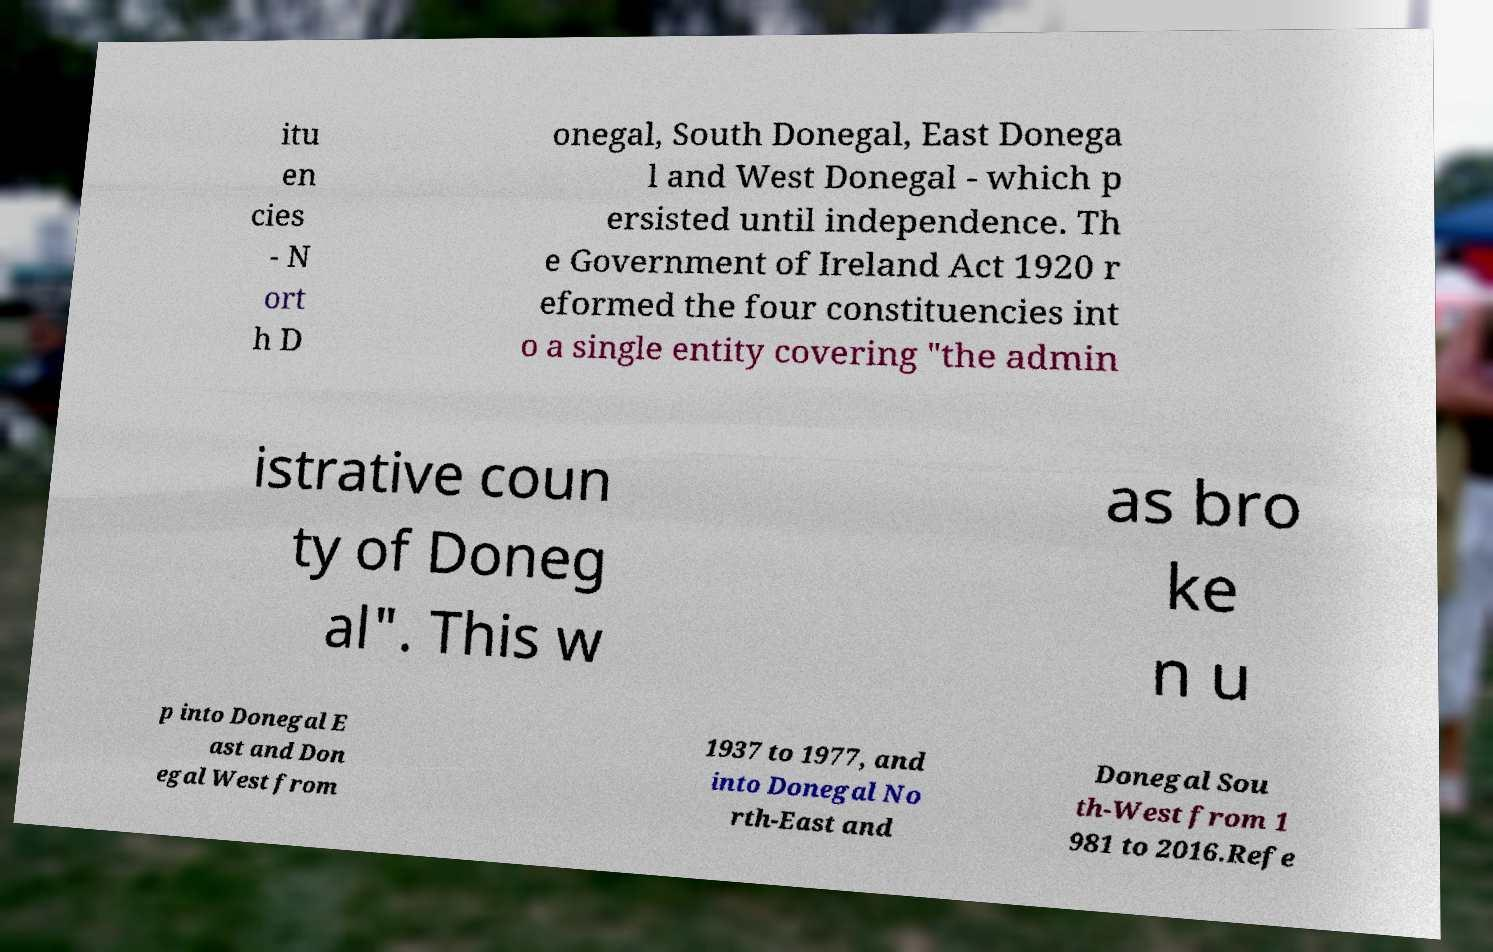Please identify and transcribe the text found in this image. itu en cies - N ort h D onegal, South Donegal, East Donega l and West Donegal - which p ersisted until independence. Th e Government of Ireland Act 1920 r eformed the four constituencies int o a single entity covering "the admin istrative coun ty of Doneg al". This w as bro ke n u p into Donegal E ast and Don egal West from 1937 to 1977, and into Donegal No rth-East and Donegal Sou th-West from 1 981 to 2016.Refe 